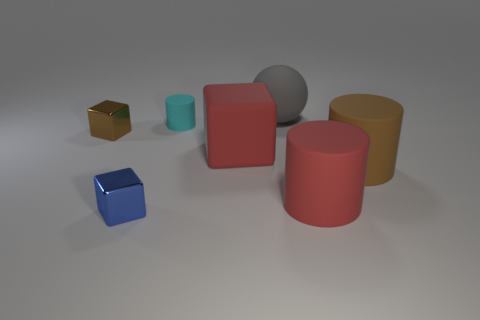There is a tiny blue block; how many tiny blocks are behind it?
Offer a very short reply. 1. There is a tiny block that is behind the red matte thing to the left of the big gray rubber thing; what is its material?
Ensure brevity in your answer.  Metal. There is a blue cube that is the same size as the cyan thing; what material is it?
Provide a short and direct response. Metal. Is there a rubber thing that has the same size as the red cube?
Offer a very short reply. Yes. The cylinder behind the big red cube is what color?
Offer a very short reply. Cyan. Is there a cyan cylinder that is in front of the tiny thing that is in front of the large red matte cylinder?
Give a very brief answer. No. How many other objects are there of the same color as the sphere?
Keep it short and to the point. 0. Do the blue metal object that is in front of the brown cube and the block right of the small cyan object have the same size?
Offer a terse response. No. There is a brown object that is to the left of the thing behind the cyan cylinder; what is its size?
Provide a succinct answer. Small. What is the material of the object that is both on the left side of the tiny cylinder and on the right side of the brown metal object?
Provide a succinct answer. Metal. 